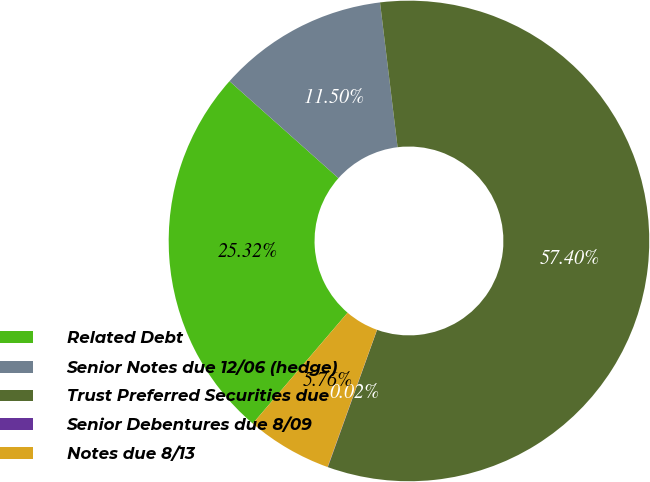<chart> <loc_0><loc_0><loc_500><loc_500><pie_chart><fcel>Related Debt<fcel>Senior Notes due 12/06 (hedge)<fcel>Trust Preferred Securities due<fcel>Senior Debentures due 8/09<fcel>Notes due 8/13<nl><fcel>25.32%<fcel>11.5%<fcel>57.41%<fcel>0.02%<fcel>5.76%<nl></chart> 